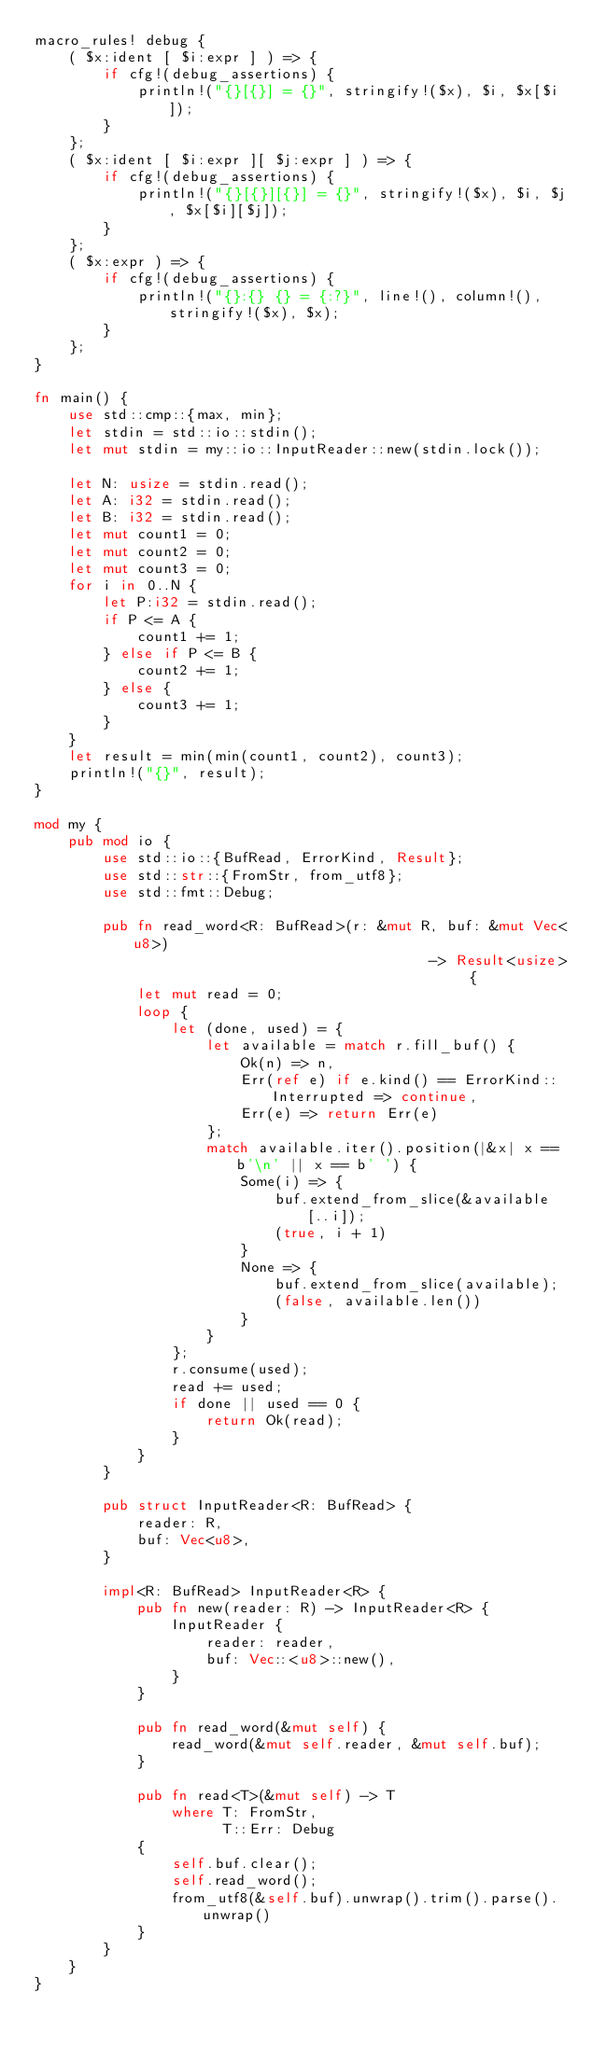<code> <loc_0><loc_0><loc_500><loc_500><_Rust_>macro_rules! debug {
    ( $x:ident [ $i:expr ] ) => {
        if cfg!(debug_assertions) {
            println!("{}[{}] = {}", stringify!($x), $i, $x[$i]);
        }
    };
    ( $x:ident [ $i:expr ][ $j:expr ] ) => {
        if cfg!(debug_assertions) {
            println!("{}[{}][{}] = {}", stringify!($x), $i, $j, $x[$i][$j]);
        }
    };
    ( $x:expr ) => {
        if cfg!(debug_assertions) {
            println!("{}:{} {} = {:?}", line!(), column!(), stringify!($x), $x);
        }
    };
}

fn main() {
    use std::cmp::{max, min};
    let stdin = std::io::stdin();
    let mut stdin = my::io::InputReader::new(stdin.lock());

    let N: usize = stdin.read();
    let A: i32 = stdin.read();
    let B: i32 = stdin.read();
    let mut count1 = 0;
    let mut count2 = 0;
    let mut count3 = 0;
    for i in 0..N {
        let P:i32 = stdin.read();
        if P <= A {
            count1 += 1;
        } else if P <= B {
            count2 += 1;
        } else {
            count3 += 1;
        }
    }
    let result = min(min(count1, count2), count3);
    println!("{}", result);
}

mod my {
    pub mod io {
        use std::io::{BufRead, ErrorKind, Result};
        use std::str::{FromStr, from_utf8};
        use std::fmt::Debug;

        pub fn read_word<R: BufRead>(r: &mut R, buf: &mut Vec<u8>)
                                              -> Result<usize> {
            let mut read = 0;
            loop {
                let (done, used) = {
                    let available = match r.fill_buf() {
                        Ok(n) => n,
                        Err(ref e) if e.kind() == ErrorKind::Interrupted => continue,
                        Err(e) => return Err(e)
                    };
                    match available.iter().position(|&x| x == b'\n' || x == b' ') {
                        Some(i) => {
                            buf.extend_from_slice(&available[..i]);
                            (true, i + 1)
                        }
                        None => {
                            buf.extend_from_slice(available);
                            (false, available.len())
                        }
                    }
                };
                r.consume(used);
                read += used;
                if done || used == 0 {
                    return Ok(read);
                }
            }
        }

        pub struct InputReader<R: BufRead> {
            reader: R,
            buf: Vec<u8>,
        }

        impl<R: BufRead> InputReader<R> {
            pub fn new(reader: R) -> InputReader<R> {
                InputReader {
                    reader: reader,
                    buf: Vec::<u8>::new(),
                }
            }

            pub fn read_word(&mut self) {
                read_word(&mut self.reader, &mut self.buf);
            }
            
            pub fn read<T>(&mut self) -> T
                where T: FromStr,
                      T::Err: Debug
            {
                self.buf.clear();
                self.read_word();
                from_utf8(&self.buf).unwrap().trim().parse().unwrap()
            }
        }
    }
}

</code> 